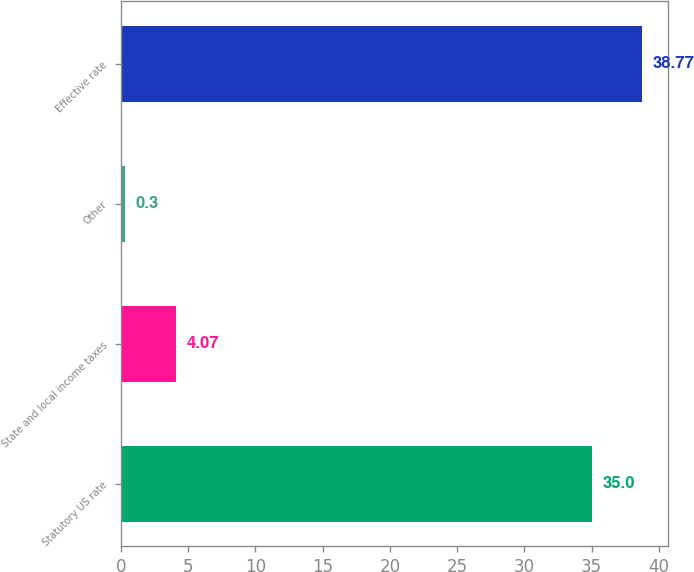Convert chart to OTSL. <chart><loc_0><loc_0><loc_500><loc_500><bar_chart><fcel>Statutory US rate<fcel>State and local income taxes<fcel>Other<fcel>Effective rate<nl><fcel>35<fcel>4.07<fcel>0.3<fcel>38.77<nl></chart> 